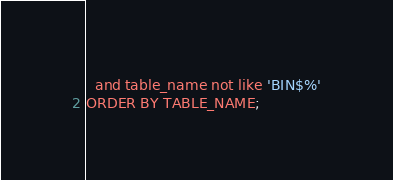Convert code to text. <code><loc_0><loc_0><loc_500><loc_500><_SQL_>  and table_name not like 'BIN$%'
ORDER BY TABLE_NAME;
</code> 